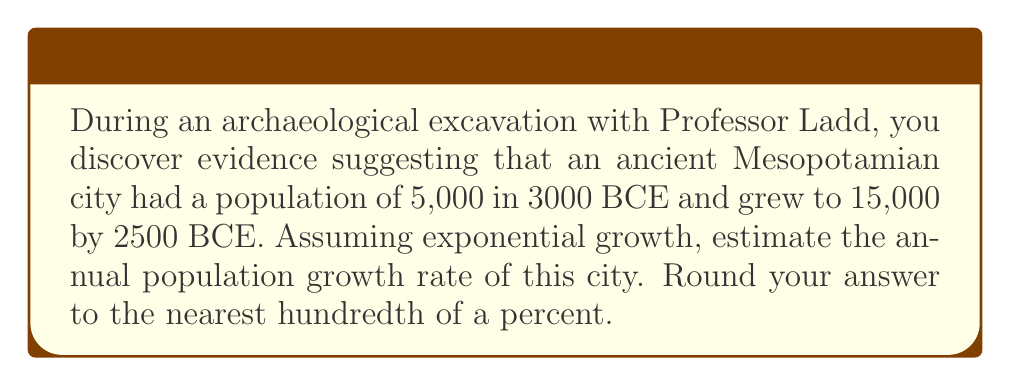Could you help me with this problem? To solve this problem, we'll use the exponential growth formula:

$$A = P(1 + r)^t$$

Where:
$A$ = Final amount (population)
$P$ = Initial amount (population)
$r$ = Annual growth rate (in decimal form)
$t$ = Time period (in years)

Given:
$P = 5,000$ (initial population in 3000 BCE)
$A = 15,000$ (final population in 2500 BCE)
$t = 500$ years (from 3000 BCE to 2500 BCE)

Step 1: Substitute the known values into the formula:
$$15,000 = 5,000(1 + r)^{500}$$

Step 2: Divide both sides by 5,000:
$$3 = (1 + r)^{500}$$

Step 3: Take the 500th root of both sides:
$$\sqrt[500]{3} = 1 + r$$

Step 4: Subtract 1 from both sides:
$$\sqrt[500]{3} - 1 = r$$

Step 5: Calculate the value of $r$:
$$r \approx 0.002205$$

Step 6: Convert to a percentage and round to the nearest hundredth:
$$r \approx 0.002205 \times 100\% \approx 0.22\%$$

Therefore, the estimated annual population growth rate is approximately 0.22%.
Answer: 0.22% 